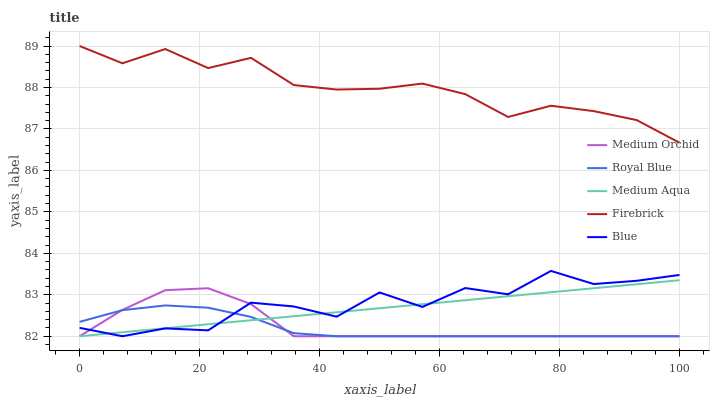Does Royal Blue have the minimum area under the curve?
Answer yes or no. Yes. Does Firebrick have the maximum area under the curve?
Answer yes or no. Yes. Does Firebrick have the minimum area under the curve?
Answer yes or no. No. Does Royal Blue have the maximum area under the curve?
Answer yes or no. No. Is Medium Aqua the smoothest?
Answer yes or no. Yes. Is Blue the roughest?
Answer yes or no. Yes. Is Royal Blue the smoothest?
Answer yes or no. No. Is Royal Blue the roughest?
Answer yes or no. No. Does Blue have the lowest value?
Answer yes or no. Yes. Does Firebrick have the lowest value?
Answer yes or no. No. Does Firebrick have the highest value?
Answer yes or no. Yes. Does Royal Blue have the highest value?
Answer yes or no. No. Is Royal Blue less than Firebrick?
Answer yes or no. Yes. Is Firebrick greater than Royal Blue?
Answer yes or no. Yes. Does Medium Orchid intersect Royal Blue?
Answer yes or no. Yes. Is Medium Orchid less than Royal Blue?
Answer yes or no. No. Is Medium Orchid greater than Royal Blue?
Answer yes or no. No. Does Royal Blue intersect Firebrick?
Answer yes or no. No. 